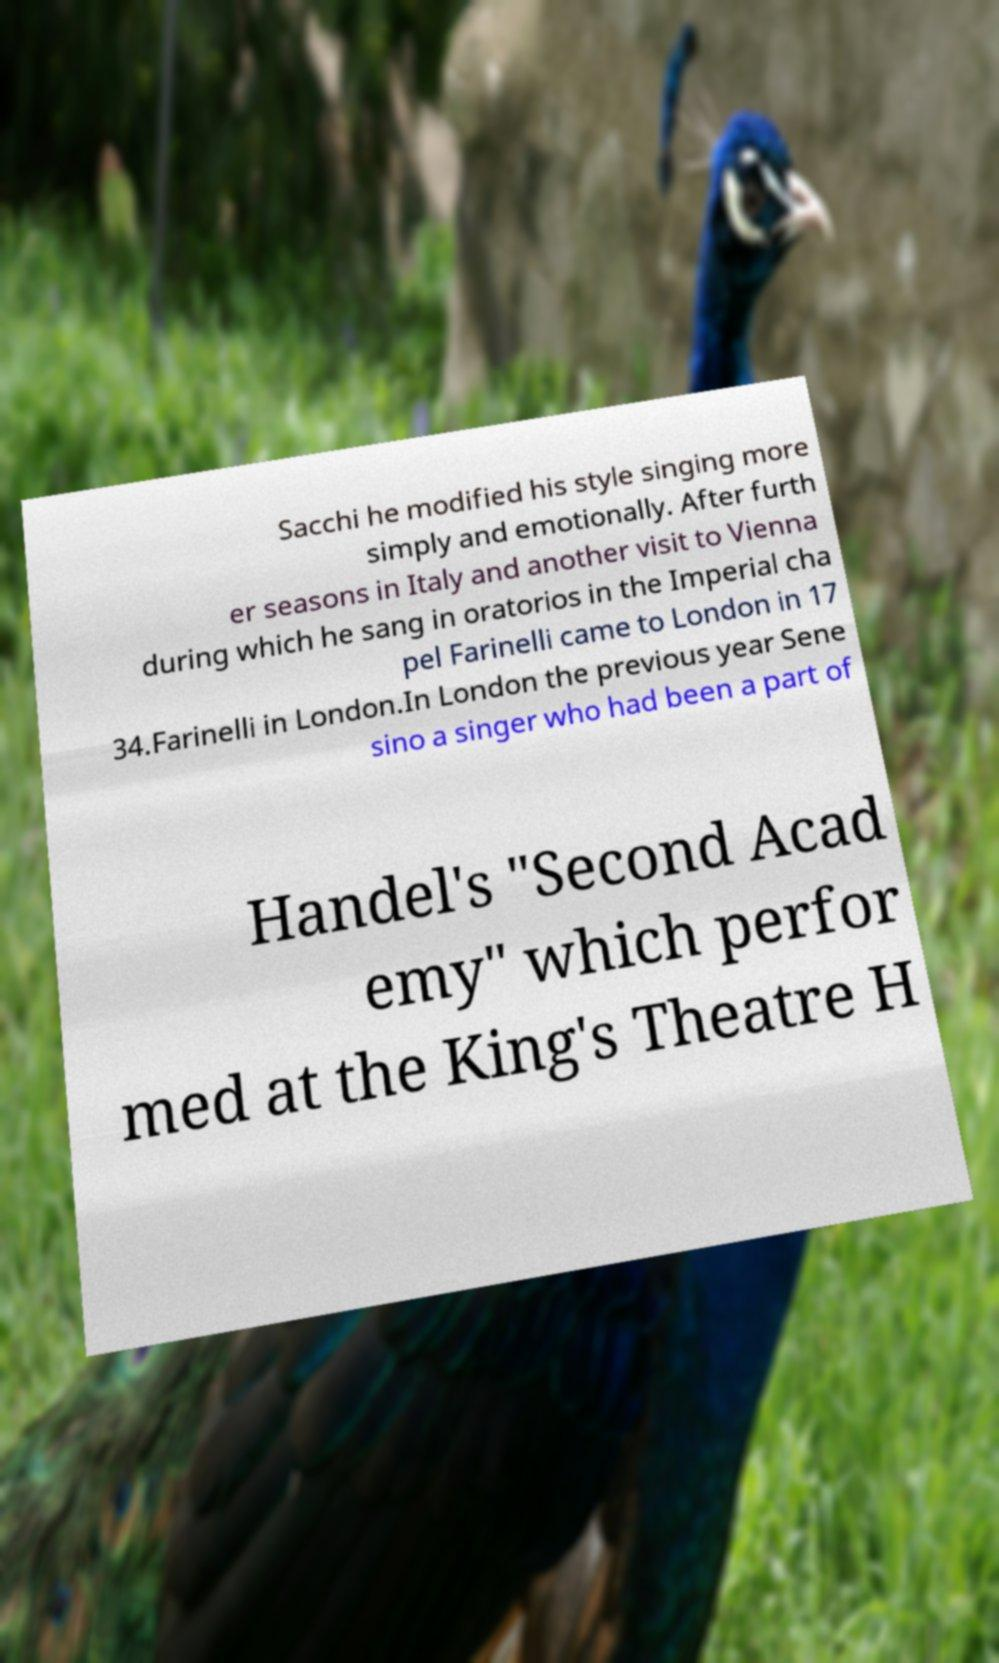Please identify and transcribe the text found in this image. Sacchi he modified his style singing more simply and emotionally. After furth er seasons in Italy and another visit to Vienna during which he sang in oratorios in the Imperial cha pel Farinelli came to London in 17 34.Farinelli in London.In London the previous year Sene sino a singer who had been a part of Handel's "Second Acad emy" which perfor med at the King's Theatre H 